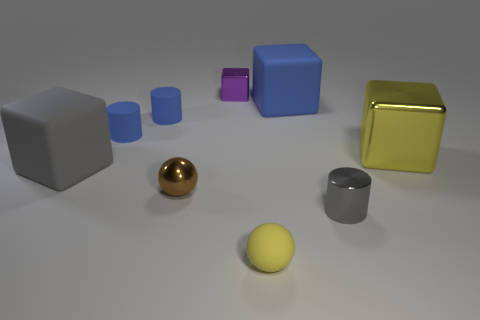Subtract all balls. How many objects are left? 7 Subtract 0 green cubes. How many objects are left? 9 Subtract all tiny brown shiny balls. Subtract all small gray metallic cylinders. How many objects are left? 7 Add 1 tiny brown spheres. How many tiny brown spheres are left? 2 Add 6 shiny cylinders. How many shiny cylinders exist? 7 